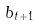Convert formula to latex. <formula><loc_0><loc_0><loc_500><loc_500>b _ { t + 1 }</formula> 